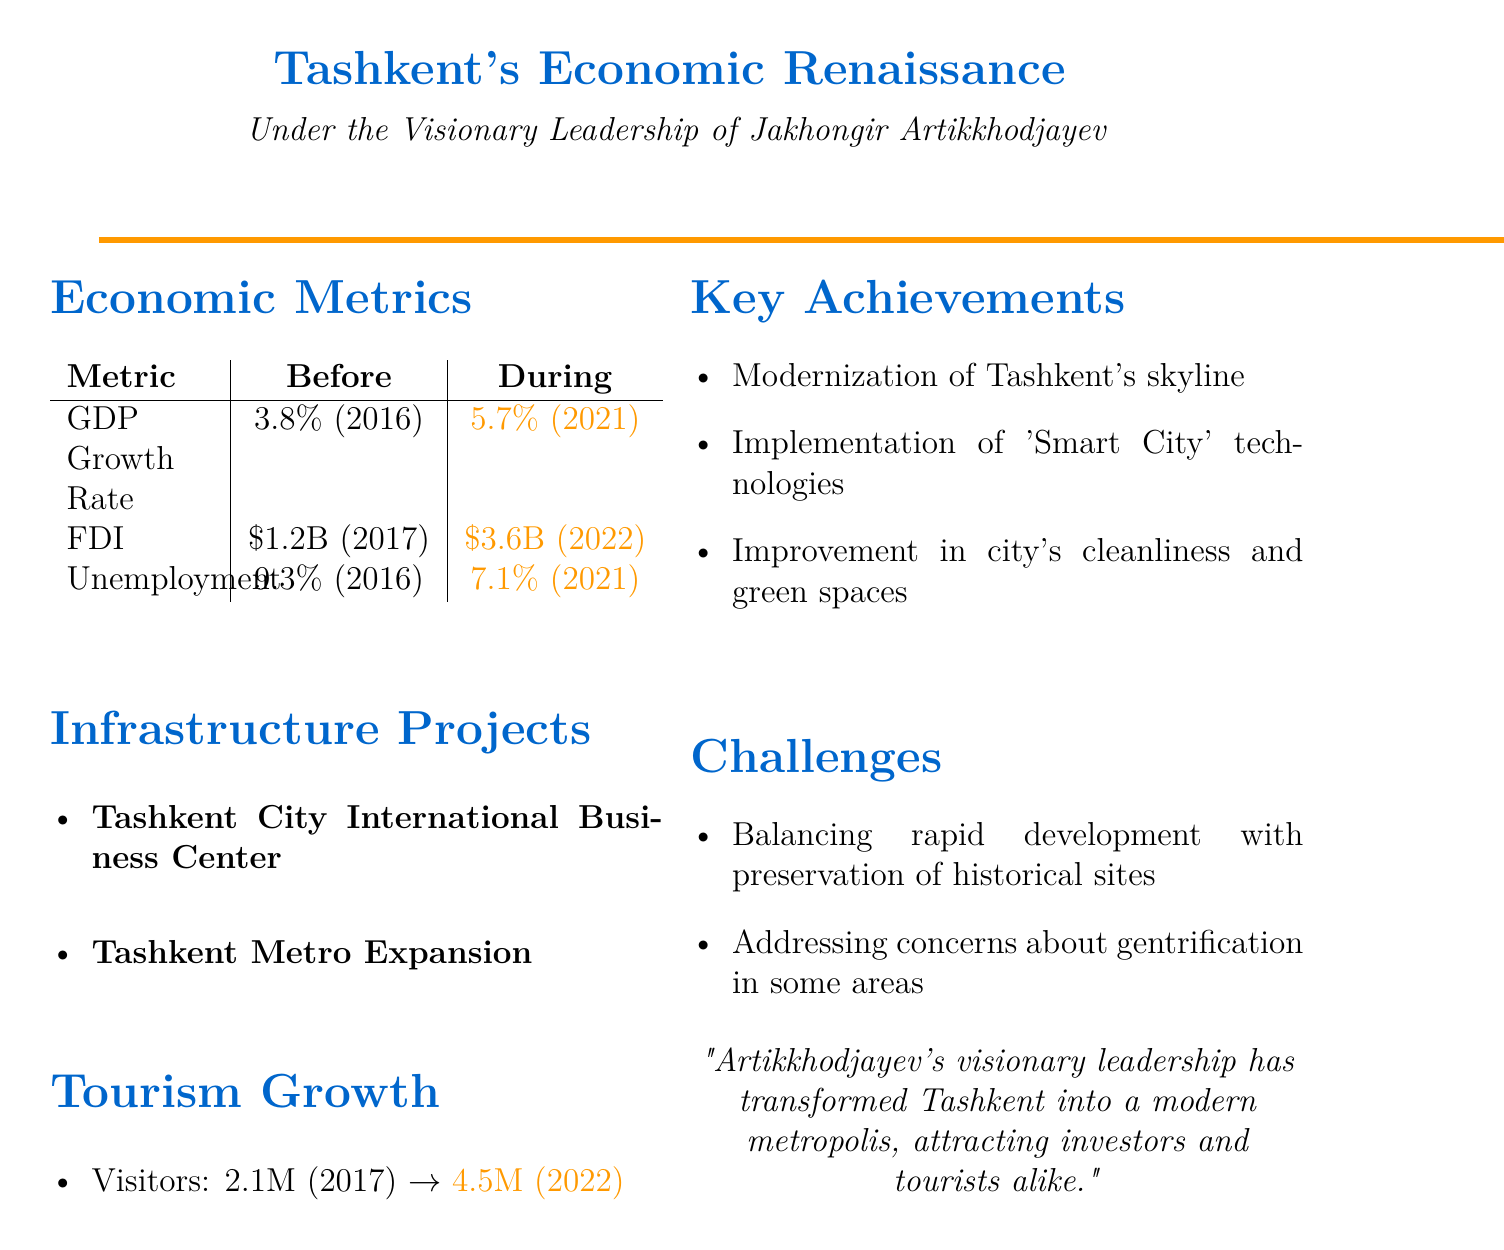What was the GDP growth rate in 2016? The GDP growth rate before Artikkhodjayev's tenure was recorded as 3.8% in 2016.
Answer: 3.8% What was the foreign direct investment in 2022? During Artikkhodjayev's tenure, the foreign direct investment reached $3.6 billion in 2022.
Answer: $3.6 billion What is the unemployment rate during Artikkhodjayev's tenure in 2021? The unemployment rate decreased to 7.1% during Artikkhodjayev's leadership in 2021.
Answer: 7.1% How many visitors did Tashkent have in 2022? The tourism stats show that Tashkent had 4.5 million visitors in 2022.
Answer: 4.5 million What significant project was initiated by Artikkhodjayev? One major project initiated by Artikkhodjayev is the Tashkent City International Business Center.
Answer: Tashkent City International Business Center What was one of the challenges faced during Artikkhodjayev's tenure? A challenge mentioned is balancing rapid development with preservation of historical sites.
Answer: Preservation of historical sites Which year had the highest GDP growth rate before and during Artikkhodjayev's tenure? The highest GDP growth rate during his tenure was 5.7% in 2021 compared to 3.8% in 2016.
Answer: 5.7% What was the comment on unemployment rate improvement? The document comments on the reduced unemployment through job creation initiatives.
Answer: Job creation initiatives Which technologies were implemented in Tashkent under Artikkhodjayev? The document states that 'Smart City' technologies were implemented during Artikkhodjayev's leadership.
Answer: 'Smart City' technologies 